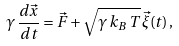<formula> <loc_0><loc_0><loc_500><loc_500>\gamma \, \frac { d \vec { x } } { d t } = \vec { F } + \sqrt { \gamma \, k _ { B } \, T } \, \vec { \xi } ( t ) \, ,</formula> 